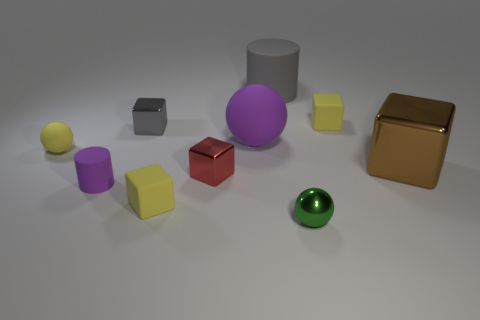Subtract all tiny red shiny cubes. How many cubes are left? 4 Subtract all red blocks. How many blocks are left? 4 Subtract all green cubes. Subtract all yellow cylinders. How many cubes are left? 5 Subtract all cylinders. How many objects are left? 8 Add 5 yellow rubber objects. How many yellow rubber objects exist? 8 Subtract 0 cyan spheres. How many objects are left? 10 Subtract all large purple rubber cubes. Subtract all large gray rubber cylinders. How many objects are left? 9 Add 6 yellow rubber balls. How many yellow rubber balls are left? 7 